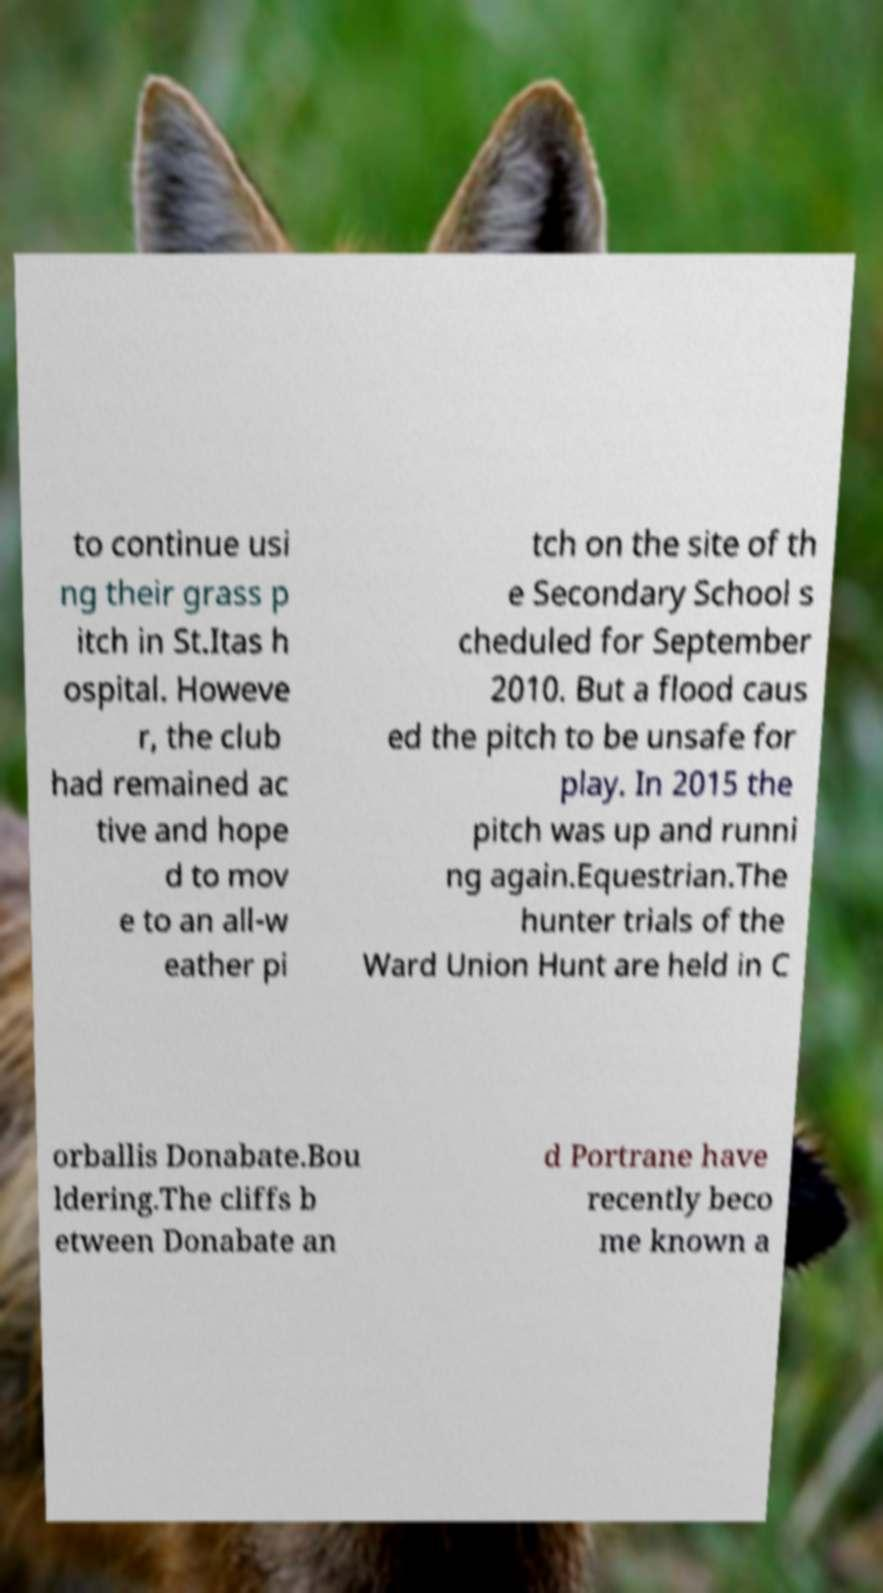Could you extract and type out the text from this image? to continue usi ng their grass p itch in St.Itas h ospital. Howeve r, the club had remained ac tive and hope d to mov e to an all-w eather pi tch on the site of th e Secondary School s cheduled for September 2010. But a flood caus ed the pitch to be unsafe for play. In 2015 the pitch was up and runni ng again.Equestrian.The hunter trials of the Ward Union Hunt are held in C orballis Donabate.Bou ldering.The cliffs b etween Donabate an d Portrane have recently beco me known a 